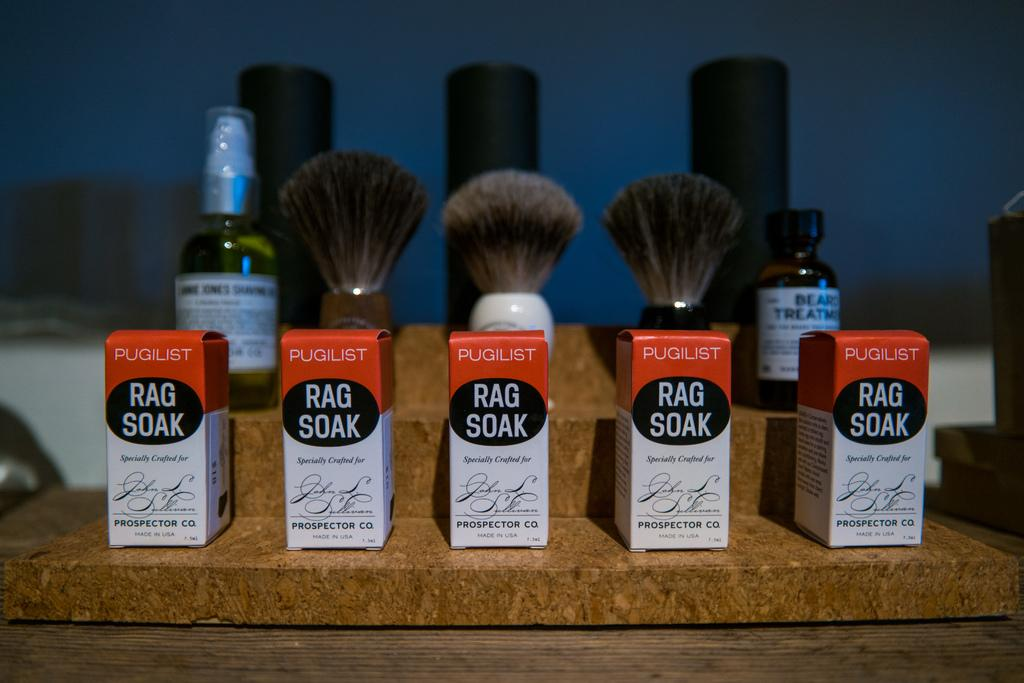Provide a one-sentence caption for the provided image. Five boxes of Pugilist Rag Soak in front of 3 shave brushes. 